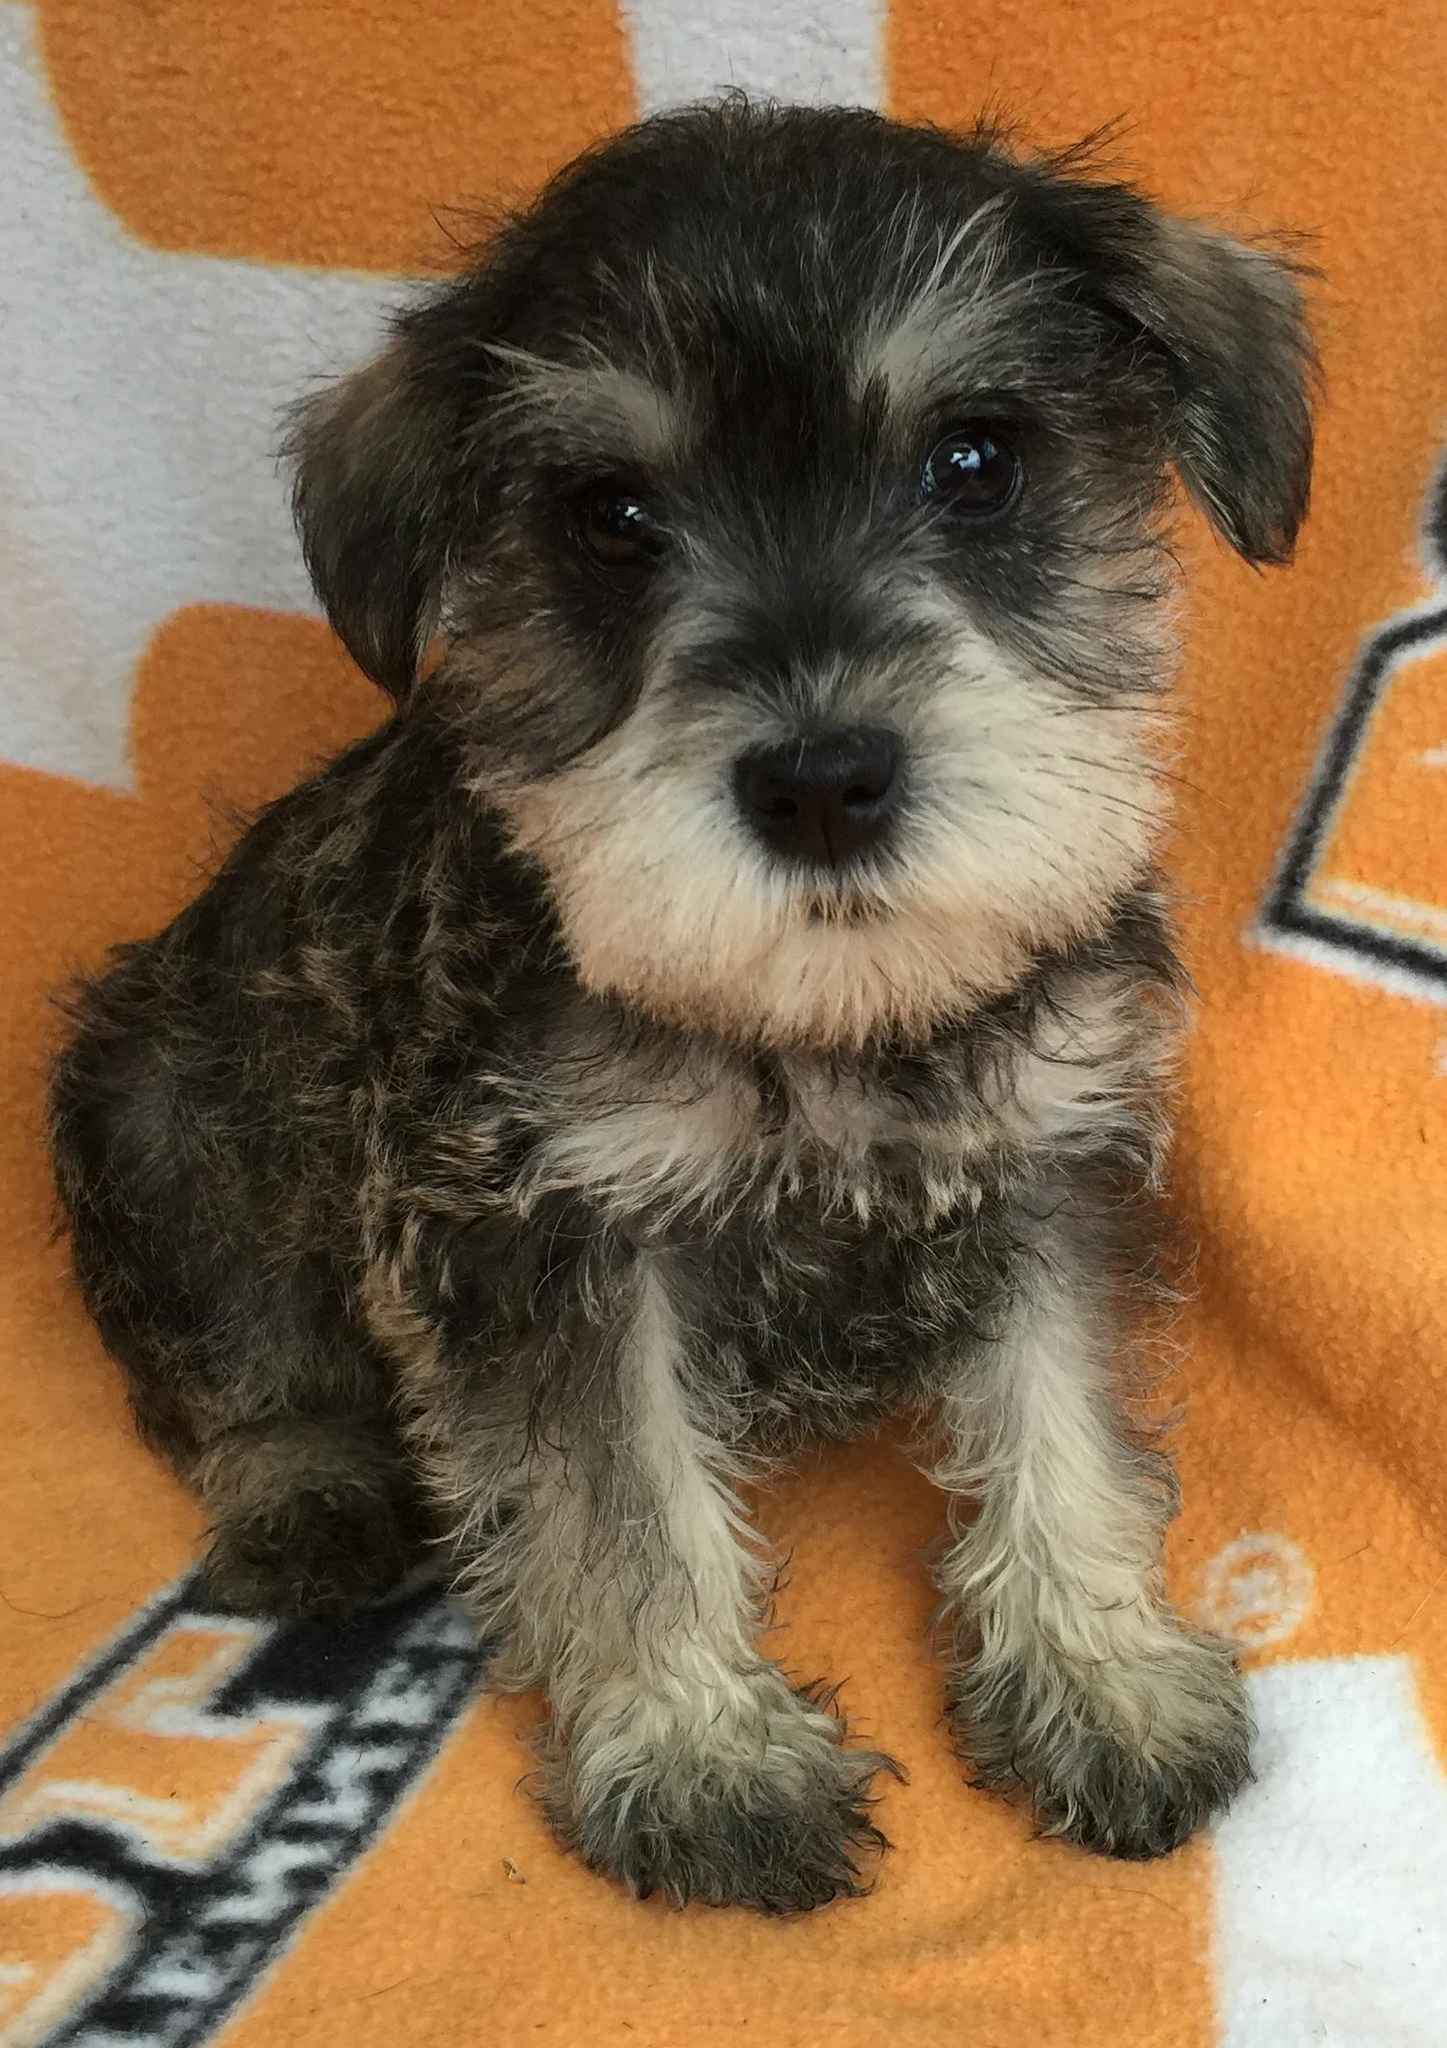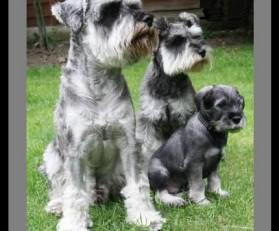The first image is the image on the left, the second image is the image on the right. Given the left and right images, does the statement "The right image contains no more than one dog." hold true? Answer yes or no. No. The first image is the image on the left, the second image is the image on the right. For the images displayed, is the sentence "There are at most two dogs." factually correct? Answer yes or no. No. 